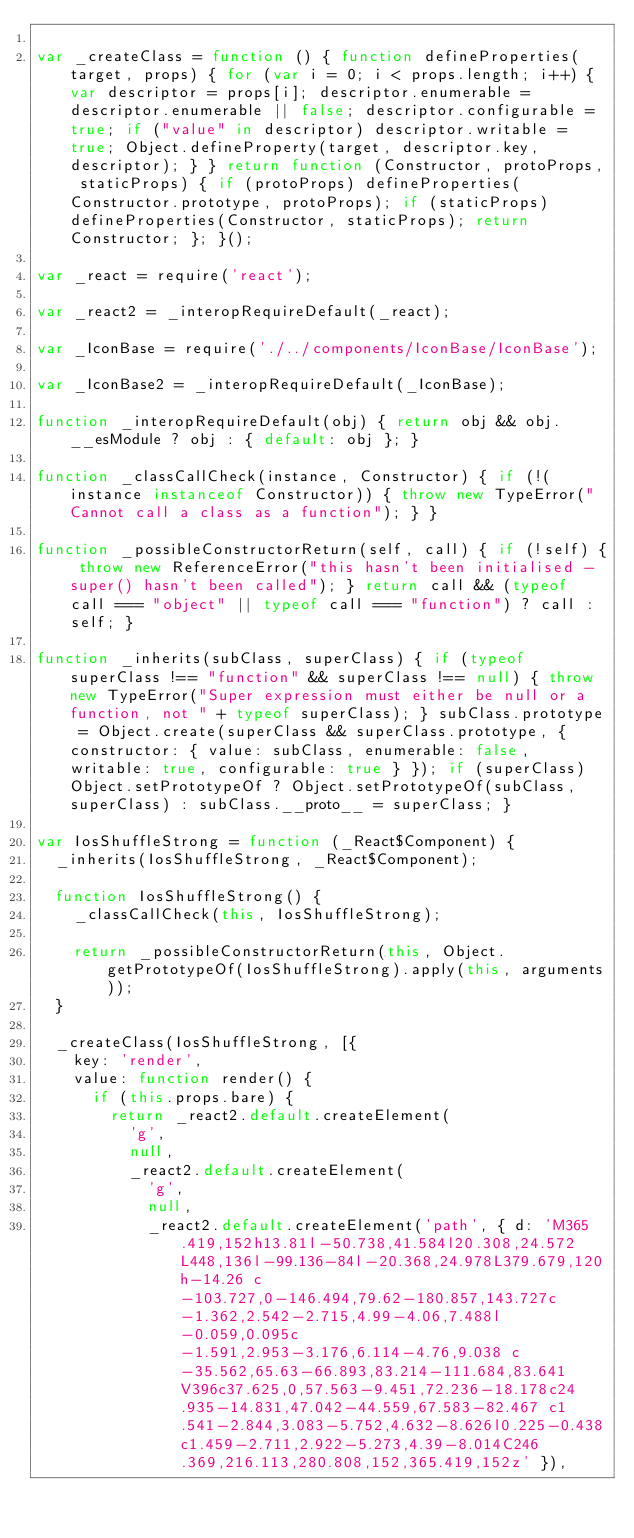<code> <loc_0><loc_0><loc_500><loc_500><_JavaScript_>
var _createClass = function () { function defineProperties(target, props) { for (var i = 0; i < props.length; i++) { var descriptor = props[i]; descriptor.enumerable = descriptor.enumerable || false; descriptor.configurable = true; if ("value" in descriptor) descriptor.writable = true; Object.defineProperty(target, descriptor.key, descriptor); } } return function (Constructor, protoProps, staticProps) { if (protoProps) defineProperties(Constructor.prototype, protoProps); if (staticProps) defineProperties(Constructor, staticProps); return Constructor; }; }();

var _react = require('react');

var _react2 = _interopRequireDefault(_react);

var _IconBase = require('./../components/IconBase/IconBase');

var _IconBase2 = _interopRequireDefault(_IconBase);

function _interopRequireDefault(obj) { return obj && obj.__esModule ? obj : { default: obj }; }

function _classCallCheck(instance, Constructor) { if (!(instance instanceof Constructor)) { throw new TypeError("Cannot call a class as a function"); } }

function _possibleConstructorReturn(self, call) { if (!self) { throw new ReferenceError("this hasn't been initialised - super() hasn't been called"); } return call && (typeof call === "object" || typeof call === "function") ? call : self; }

function _inherits(subClass, superClass) { if (typeof superClass !== "function" && superClass !== null) { throw new TypeError("Super expression must either be null or a function, not " + typeof superClass); } subClass.prototype = Object.create(superClass && superClass.prototype, { constructor: { value: subClass, enumerable: false, writable: true, configurable: true } }); if (superClass) Object.setPrototypeOf ? Object.setPrototypeOf(subClass, superClass) : subClass.__proto__ = superClass; }

var IosShuffleStrong = function (_React$Component) {
	_inherits(IosShuffleStrong, _React$Component);

	function IosShuffleStrong() {
		_classCallCheck(this, IosShuffleStrong);

		return _possibleConstructorReturn(this, Object.getPrototypeOf(IosShuffleStrong).apply(this, arguments));
	}

	_createClass(IosShuffleStrong, [{
		key: 'render',
		value: function render() {
			if (this.props.bare) {
				return _react2.default.createElement(
					'g',
					null,
					_react2.default.createElement(
						'g',
						null,
						_react2.default.createElement('path', { d: 'M365.419,152h13.81l-50.738,41.584l20.308,24.572L448,136l-99.136-84l-20.368,24.978L379.679,120h-14.26 c-103.727,0-146.494,79.62-180.857,143.727c-1.362,2.542-2.715,4.99-4.06,7.488l-0.059,0.095c-1.591,2.953-3.176,6.114-4.76,9.038 c-35.562,65.63-66.893,83.214-111.684,83.641V396c37.625,0,57.563-9.451,72.236-18.178c24.935-14.831,47.042-44.559,67.583-82.467 c1.541-2.844,3.083-5.752,4.632-8.626l0.225-0.438c1.459-2.711,2.922-5.273,4.39-8.014C246.369,216.113,280.808,152,365.419,152z' }),</code> 